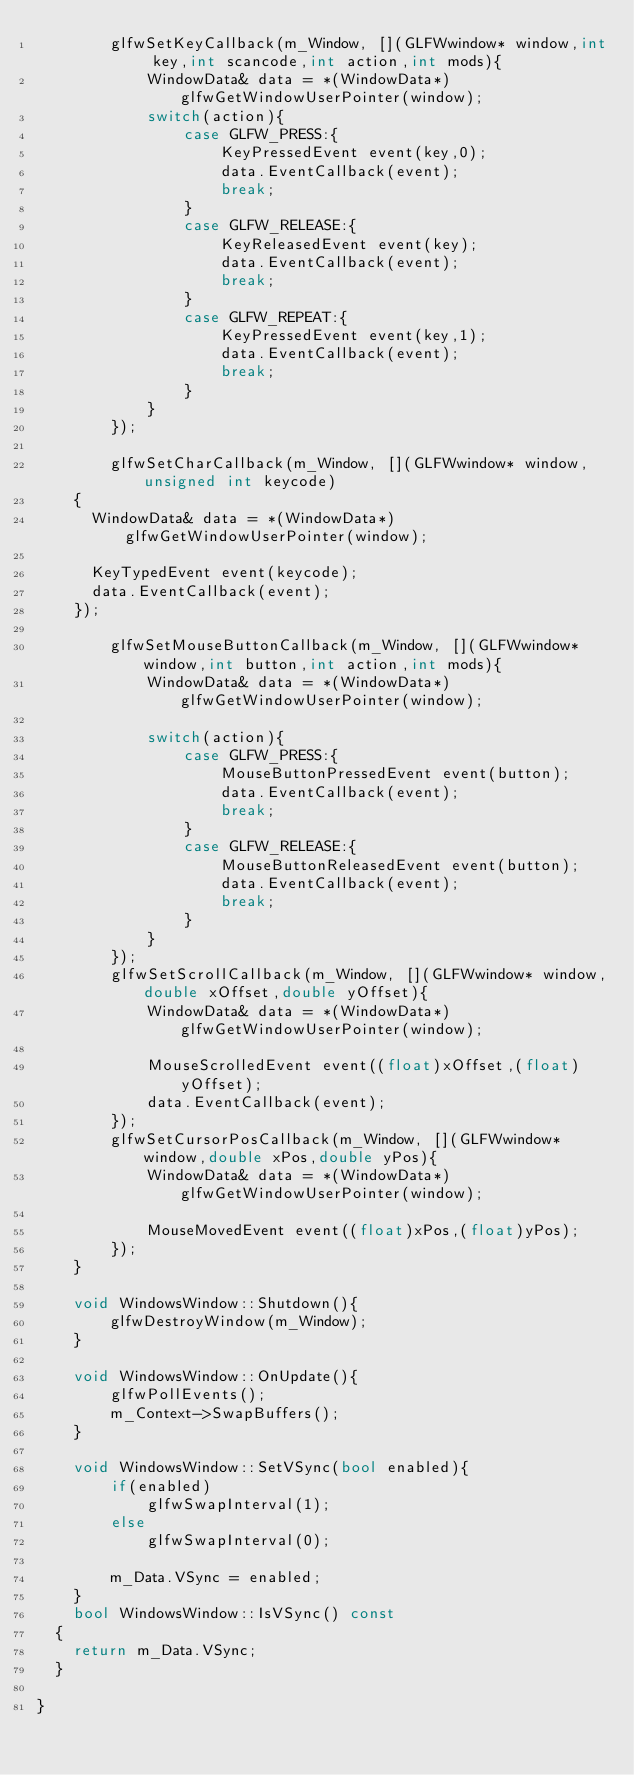<code> <loc_0><loc_0><loc_500><loc_500><_C++_>        glfwSetKeyCallback(m_Window, [](GLFWwindow* window,int key,int scancode,int action,int mods){
            WindowData& data = *(WindowData*)glfwGetWindowUserPointer(window);
            switch(action){
                case GLFW_PRESS:{
                    KeyPressedEvent event(key,0);
                    data.EventCallback(event);
                    break;
                }
                case GLFW_RELEASE:{
                    KeyReleasedEvent event(key);
                    data.EventCallback(event);
                    break;
                }
                case GLFW_REPEAT:{
                    KeyPressedEvent event(key,1);
                    data.EventCallback(event);
                    break;
                }
            }
        });

        glfwSetCharCallback(m_Window, [](GLFWwindow* window, unsigned int keycode)
		{
			WindowData& data = *(WindowData*)glfwGetWindowUserPointer(window);

			KeyTypedEvent event(keycode);
			data.EventCallback(event);
		});

        glfwSetMouseButtonCallback(m_Window, [](GLFWwindow* window,int button,int action,int mods){
            WindowData& data = *(WindowData*)glfwGetWindowUserPointer(window);

            switch(action){
                case GLFW_PRESS:{
                    MouseButtonPressedEvent event(button);
                    data.EventCallback(event);
                    break;
                }
                case GLFW_RELEASE:{
                    MouseButtonReleasedEvent event(button);
                    data.EventCallback(event);
                    break;
                }
            }
        });
        glfwSetScrollCallback(m_Window, [](GLFWwindow* window,double xOffset,double yOffset){
            WindowData& data = *(WindowData*)glfwGetWindowUserPointer(window);

            MouseScrolledEvent event((float)xOffset,(float)yOffset);
            data.EventCallback(event);
        });
        glfwSetCursorPosCallback(m_Window, [](GLFWwindow* window,double xPos,double yPos){
            WindowData& data = *(WindowData*)glfwGetWindowUserPointer(window);

            MouseMovedEvent event((float)xPos,(float)yPos);
        });
    }

    void WindowsWindow::Shutdown(){
        glfwDestroyWindow(m_Window);
    }

    void WindowsWindow::OnUpdate(){
        glfwPollEvents();
        m_Context->SwapBuffers();
    }

    void WindowsWindow::SetVSync(bool enabled){
        if(enabled)
            glfwSwapInterval(1);
        else
            glfwSwapInterval(0);
        
        m_Data.VSync = enabled;
    }
    bool WindowsWindow::IsVSync() const
	{
		return m_Data.VSync;
	}

}</code> 